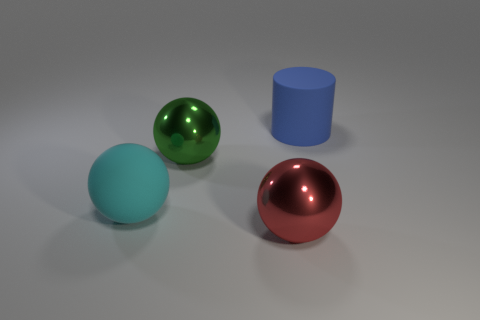What number of things are either big objects to the right of the large red metal ball or large balls that are behind the big red thing?
Offer a terse response. 3. What is the shape of the green metallic thing?
Provide a short and direct response. Sphere. How many other things are the same material as the large green ball?
Provide a short and direct response. 1. There is a large thing right of the ball in front of the big rubber thing to the left of the big cylinder; what is it made of?
Give a very brief answer. Rubber. Are any green metallic balls visible?
Ensure brevity in your answer.  Yes. What color is the big cylinder?
Your answer should be compact. Blue. Are there any other things that have the same shape as the big blue rubber thing?
Your answer should be very brief. No. There is a large rubber object that is the same shape as the large green shiny object; what color is it?
Give a very brief answer. Cyan. Does the cyan object have the same shape as the red object?
Your answer should be very brief. Yes. What number of cylinders are either large gray things or rubber things?
Ensure brevity in your answer.  1. 